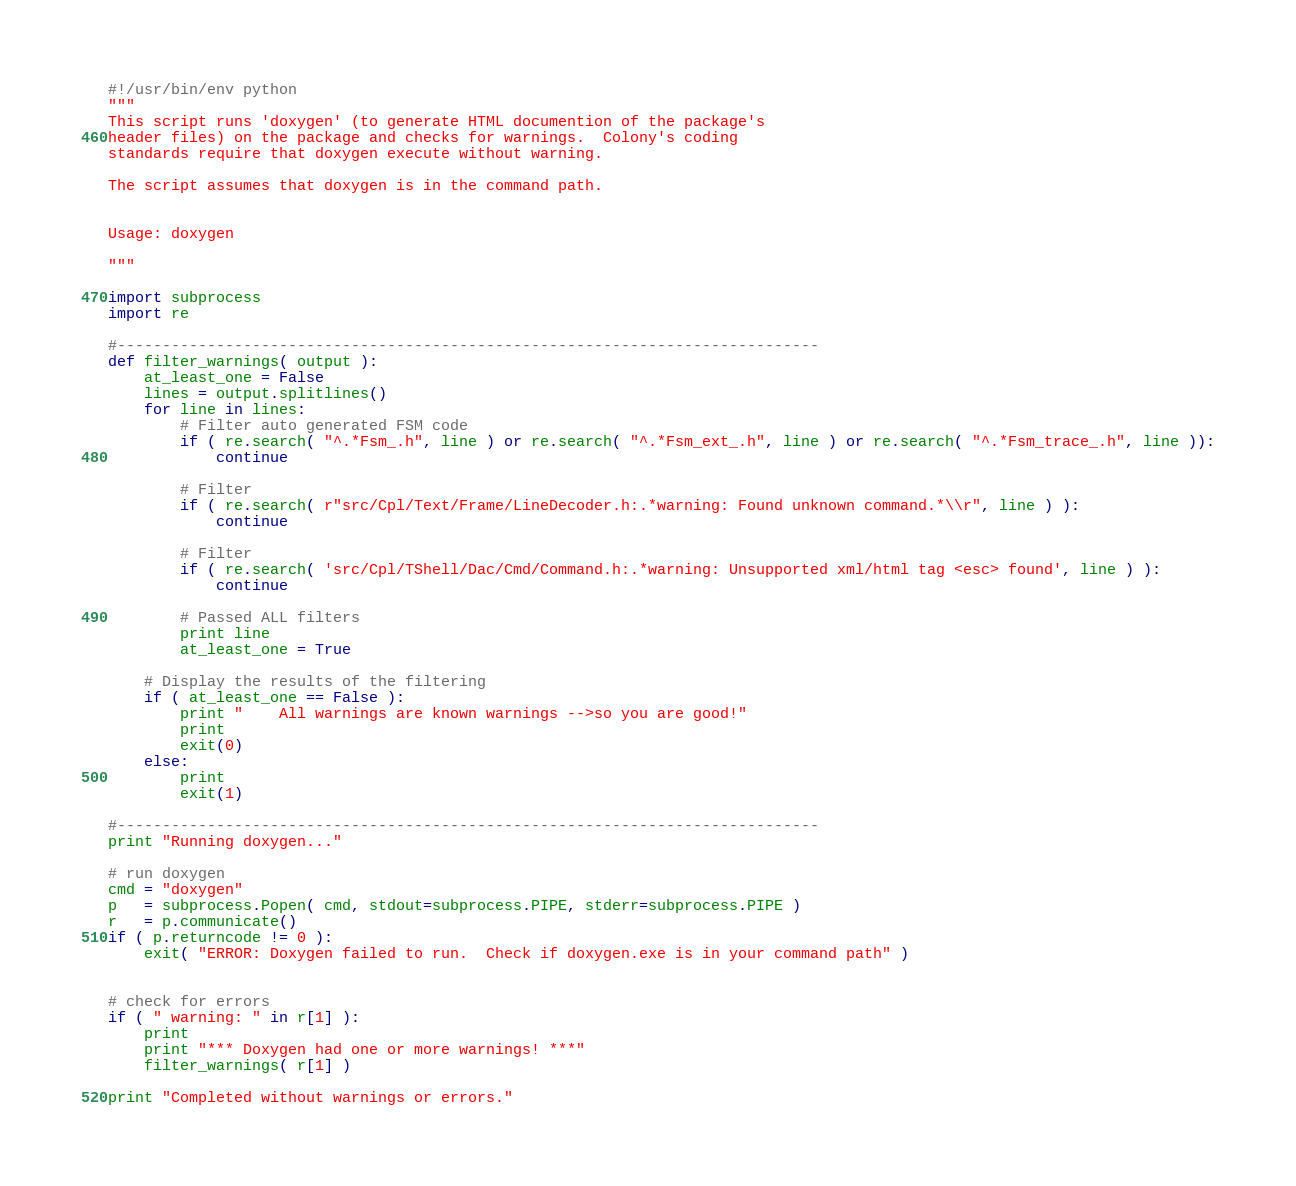Convert code to text. <code><loc_0><loc_0><loc_500><loc_500><_Python_>#!/usr/bin/env python
"""
This script runs 'doxygen' (to generate HTML documention of the package's
header files) on the package and checks for warnings.  Colony's coding 
standards require that doxygen execute without warning.

The script assumes that doxygen is in the command path.


Usage: doxygen

"""

import subprocess
import re

#------------------------------------------------------------------------------
def filter_warnings( output ):
    at_least_one = False
    lines = output.splitlines()
    for line in lines:
        # Filter auto generated FSM code
        if ( re.search( "^.*Fsm_.h", line ) or re.search( "^.*Fsm_ext_.h", line ) or re.search( "^.*Fsm_trace_.h", line )):
            continue
            
        # Filter
        if ( re.search( r"src/Cpl/Text/Frame/LineDecoder.h:.*warning: Found unknown command.*\\r", line ) ):
            continue
 
        # Filter
        if ( re.search( 'src/Cpl/TShell/Dac/Cmd/Command.h:.*warning: Unsupported xml/html tag <esc> found', line ) ):
            continue
            
        # Passed ALL filters
        print line
        at_least_one = True

    # Display the results of the filtering
    if ( at_least_one == False ):
        print "    All warnings are known warnings -->so you are good!"
        print
        exit(0)
    else:
        print
        exit(1)
        
#------------------------------------------------------------------------------
print "Running doxygen..."     

# run doxygen
cmd = "doxygen"
p   = subprocess.Popen( cmd, stdout=subprocess.PIPE, stderr=subprocess.PIPE )
r   = p.communicate()
if ( p.returncode != 0 ):
    exit( "ERROR: Doxygen failed to run.  Check if doxygen.exe is in your command path" )


# check for errors
if ( " warning: " in r[1] ):
    print
    print "*** Doxygen had one or more warnings! ***"
    filter_warnings( r[1] )
    
print "Completed without warnings or errors."
</code> 